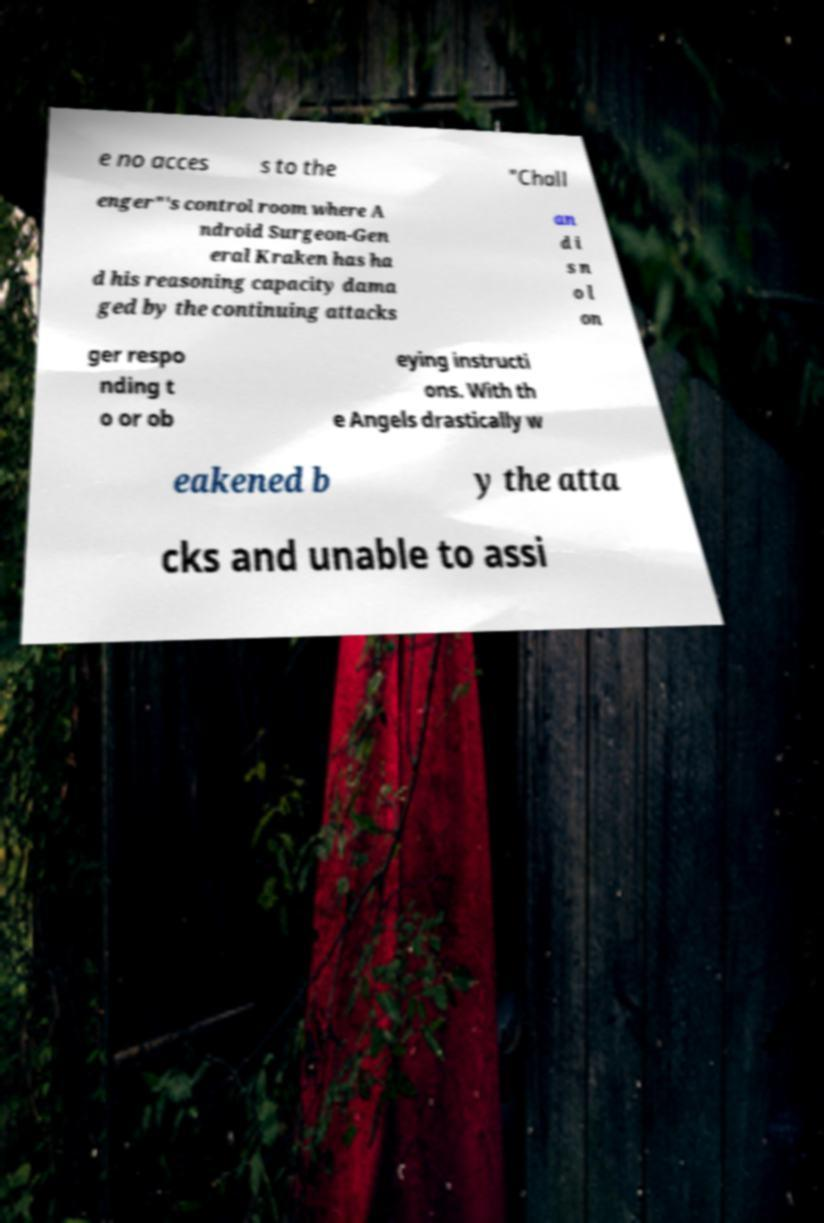Can you read and provide the text displayed in the image?This photo seems to have some interesting text. Can you extract and type it out for me? e no acces s to the "Chall enger"'s control room where A ndroid Surgeon-Gen eral Kraken has ha d his reasoning capacity dama ged by the continuing attacks an d i s n o l on ger respo nding t o or ob eying instructi ons. With th e Angels drastically w eakened b y the atta cks and unable to assi 